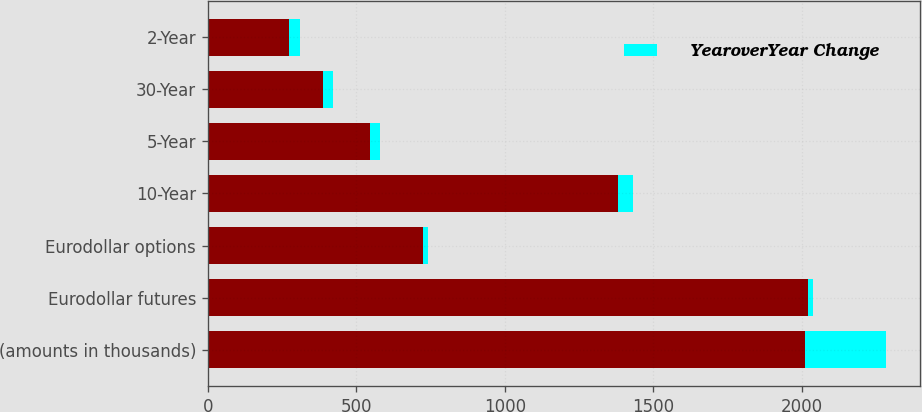Convert chart to OTSL. <chart><loc_0><loc_0><loc_500><loc_500><stacked_bar_chart><ecel><fcel>(amounts in thousands)<fcel>Eurodollar futures<fcel>Eurodollar options<fcel>10-Year<fcel>5-Year<fcel>30-Year<fcel>2-Year<nl><fcel>nan<fcel>2010<fcel>2020<fcel>726<fcel>1380<fcel>546<fcel>388<fcel>274<nl><fcel>YearoverYear Change<fcel>274<fcel>16<fcel>14<fcel>51<fcel>33<fcel>33<fcel>37<nl></chart> 